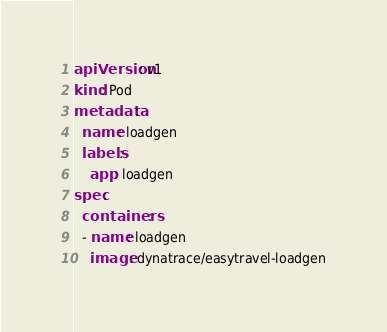<code> <loc_0><loc_0><loc_500><loc_500><_YAML_>apiVersion: v1
kind: Pod
metadata:
  name: loadgen
  labels:
    app: loadgen
spec:
  containers:
  - name: loadgen
    image: dynatrace/easytravel-loadgen</code> 